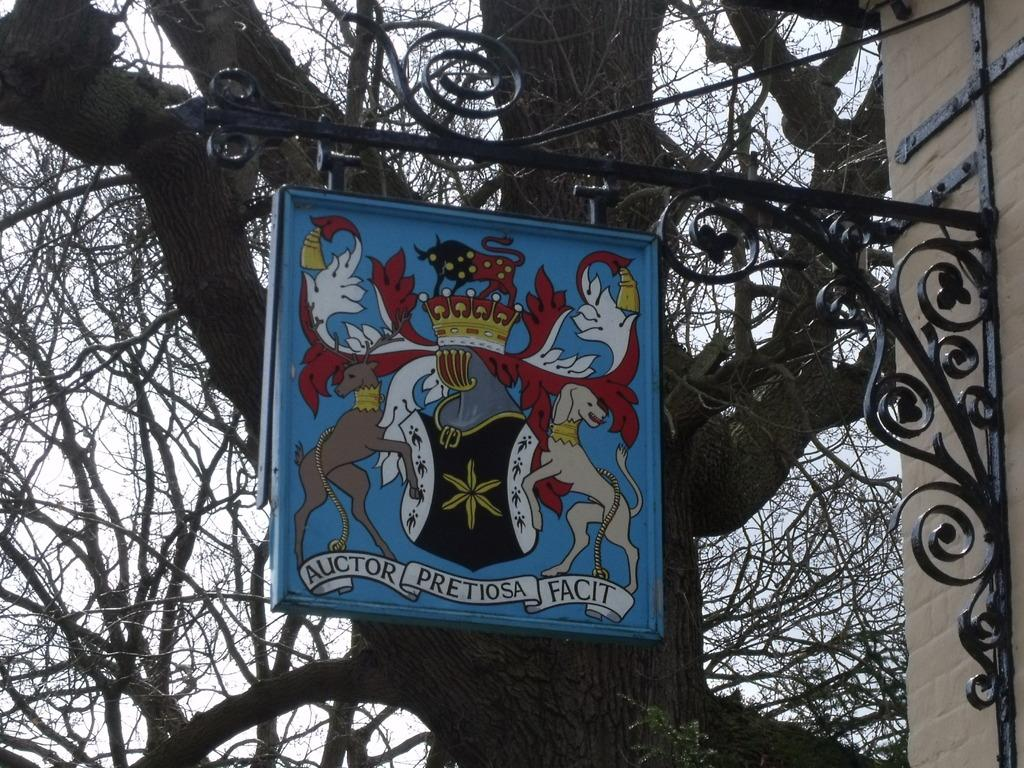What is the main object in the middle of the image? There is a board in the middle of the image. What is depicted on the board? There are paintings of dogs on the board. What can be seen in the background of the image? There are trees visible in the background of the image. What type of bone can be seen in the image? There is no bone present in the image. How many ducks are visible in the image? There are no ducks present in the image. 